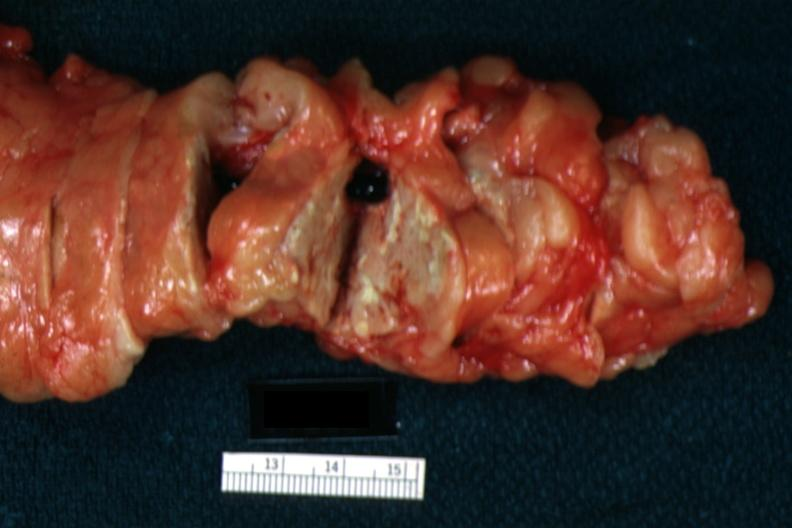s pancreas present?
Answer the question using a single word or phrase. Yes 